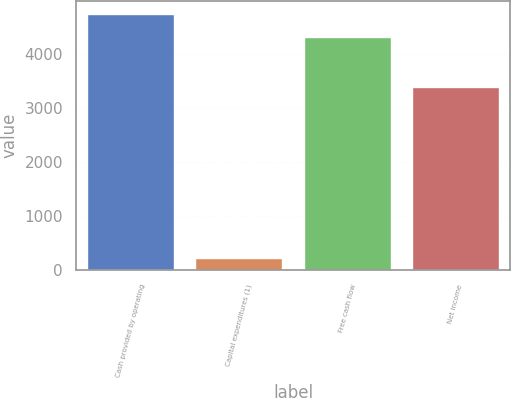<chart> <loc_0><loc_0><loc_500><loc_500><bar_chart><fcel>Cash provided by operating<fcel>Capital expenditures (1)<fcel>Free cash flow<fcel>Net income<nl><fcel>4735.5<fcel>236<fcel>4305<fcel>3381<nl></chart> 